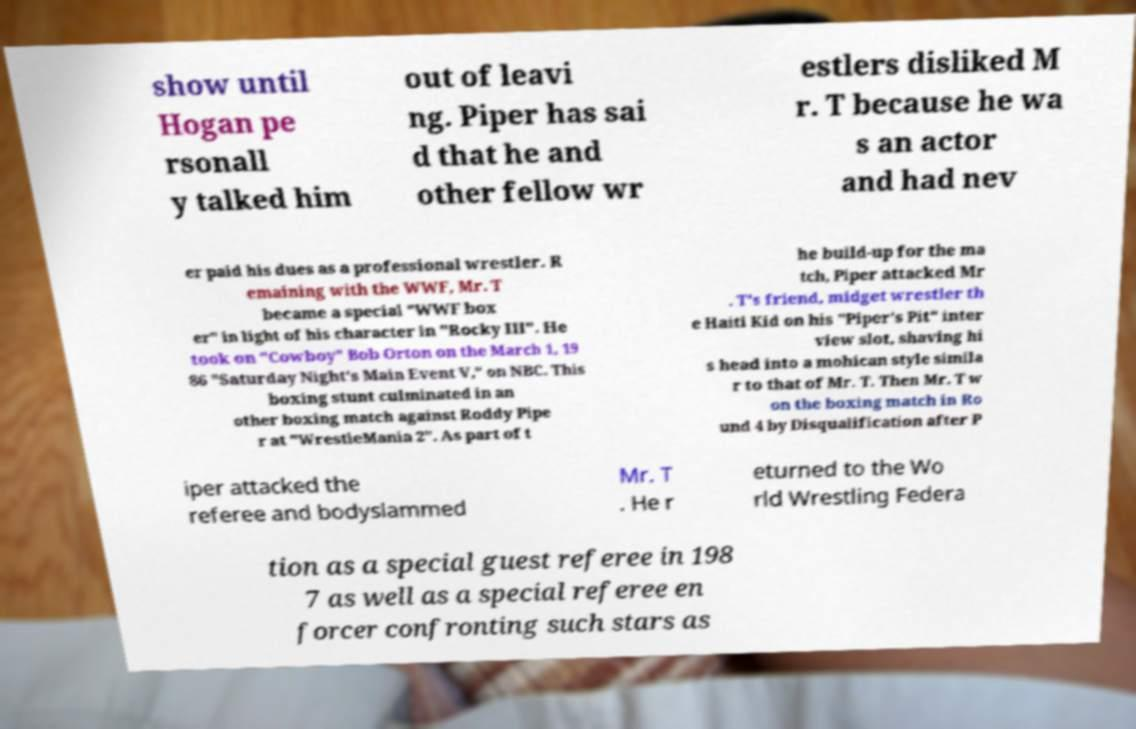Can you read and provide the text displayed in the image?This photo seems to have some interesting text. Can you extract and type it out for me? show until Hogan pe rsonall y talked him out of leavi ng. Piper has sai d that he and other fellow wr estlers disliked M r. T because he wa s an actor and had nev er paid his dues as a professional wrestler. R emaining with the WWF, Mr. T became a special "WWF box er" in light of his character in "Rocky III". He took on "Cowboy" Bob Orton on the March 1, 19 86 "Saturday Night's Main Event V," on NBC. This boxing stunt culminated in an other boxing match against Roddy Pipe r at "WrestleMania 2". As part of t he build-up for the ma tch, Piper attacked Mr . T's friend, midget wrestler th e Haiti Kid on his "Piper's Pit" inter view slot, shaving hi s head into a mohican style simila r to that of Mr. T. Then Mr. T w on the boxing match in Ro und 4 by Disqualification after P iper attacked the referee and bodyslammed Mr. T . He r eturned to the Wo rld Wrestling Federa tion as a special guest referee in 198 7 as well as a special referee en forcer confronting such stars as 